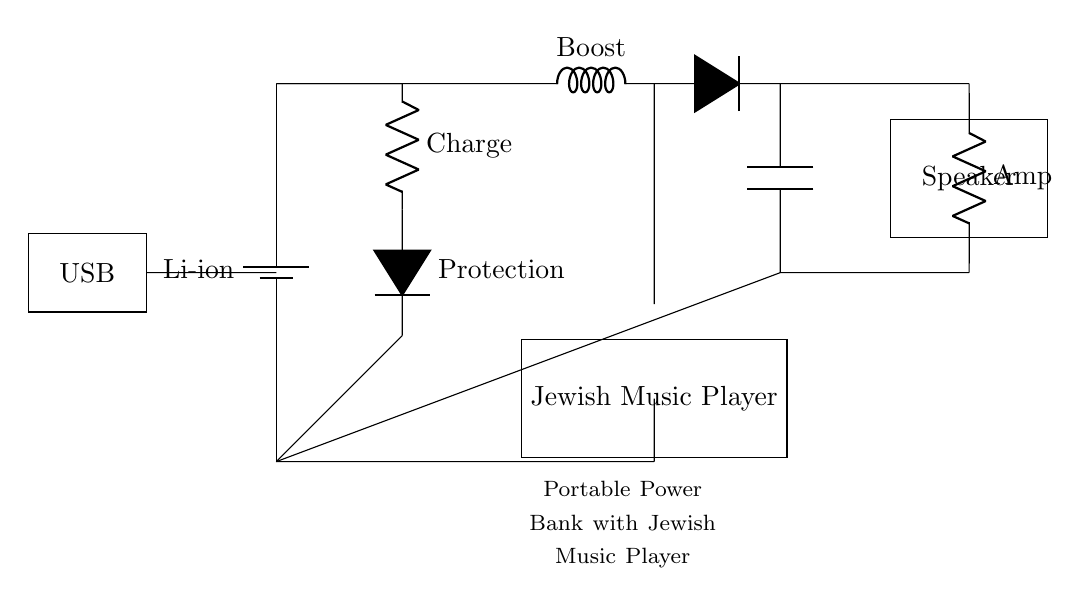what type of battery is used in the power bank? The circuit shows a lithium-ion battery labeled as "Li-ion." This indicates that this specific type of battery is used in the design for portability and efficient power storage.
Answer: Li-ion what component is connected to the USB input? The USB input is directly connected to the battery, allowing for charging. The circuit indicates the flow from USB to the battery, making it clear that the USB is for charging purposes.
Answer: Battery which component is responsible for audio amplification? The circuit features a component labeled "Amp," which stands for an audio amplifier. This component boosts the audio signal before it reaches the speaker for better sound quality.
Answer: Amp how many components are involved in the charging circuit? Counting the components labeled in the charging section, there are three, which include a resistor for charge, a protection diode, and the battery itself, which is part of the power path.
Answer: Three what does the boost converter do in this circuit? The boost converter is responsible for increasing the voltage level from the battery to a higher voltage that is suitable for driving other components like the speaker and music player. This allows for efficient power management and usage.
Answer: Increases voltage what is the purpose of the music player in this circuit? The music player is included to play traditional Jewish music, acting as a source for audio output that is then amplified and sent to the speaker. This integration allows the entire system to function as a portable music player.
Answer: Play music how does the protection diode function in this circuit? The protection diode prevents reverse current flow, ensuring that the battery is charged safely and protecting it from damage during the charging process. This is crucial for maintaining battery life and safety.
Answer: Prevents reverse current 